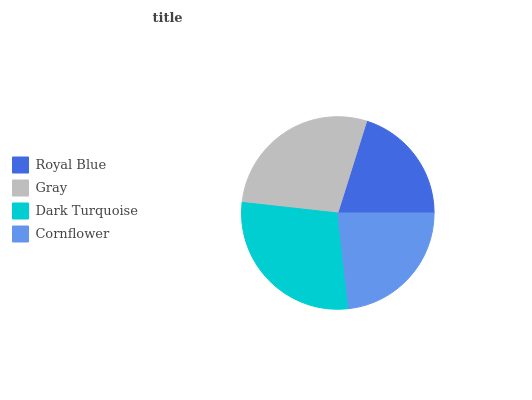Is Royal Blue the minimum?
Answer yes or no. Yes. Is Dark Turquoise the maximum?
Answer yes or no. Yes. Is Gray the minimum?
Answer yes or no. No. Is Gray the maximum?
Answer yes or no. No. Is Gray greater than Royal Blue?
Answer yes or no. Yes. Is Royal Blue less than Gray?
Answer yes or no. Yes. Is Royal Blue greater than Gray?
Answer yes or no. No. Is Gray less than Royal Blue?
Answer yes or no. No. Is Gray the high median?
Answer yes or no. Yes. Is Cornflower the low median?
Answer yes or no. Yes. Is Dark Turquoise the high median?
Answer yes or no. No. Is Royal Blue the low median?
Answer yes or no. No. 